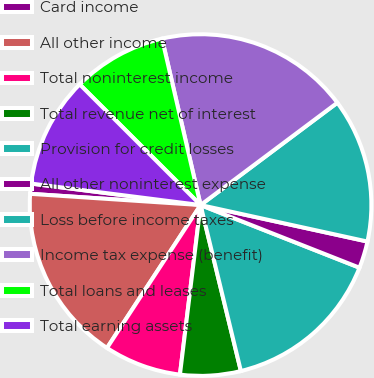Convert chart to OTSL. <chart><loc_0><loc_0><loc_500><loc_500><pie_chart><fcel>Card income<fcel>All other income<fcel>Total noninterest income<fcel>Total revenue net of interest<fcel>Provision for credit losses<fcel>All other noninterest expense<fcel>Loss before income taxes<fcel>Income tax expense (benefit)<fcel>Total loans and leases<fcel>Total earning assets<nl><fcel>0.96%<fcel>16.82%<fcel>7.3%<fcel>5.72%<fcel>15.23%<fcel>2.55%<fcel>13.65%<fcel>18.4%<fcel>8.89%<fcel>10.48%<nl></chart> 